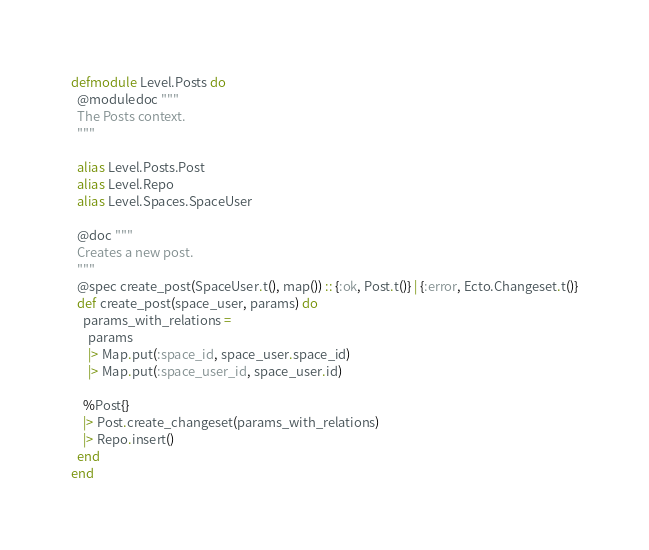Convert code to text. <code><loc_0><loc_0><loc_500><loc_500><_Elixir_>defmodule Level.Posts do
  @moduledoc """
  The Posts context.
  """

  alias Level.Posts.Post
  alias Level.Repo
  alias Level.Spaces.SpaceUser

  @doc """
  Creates a new post.
  """
  @spec create_post(SpaceUser.t(), map()) :: {:ok, Post.t()} | {:error, Ecto.Changeset.t()}
  def create_post(space_user, params) do
    params_with_relations =
      params
      |> Map.put(:space_id, space_user.space_id)
      |> Map.put(:space_user_id, space_user.id)

    %Post{}
    |> Post.create_changeset(params_with_relations)
    |> Repo.insert()
  end
end
</code> 